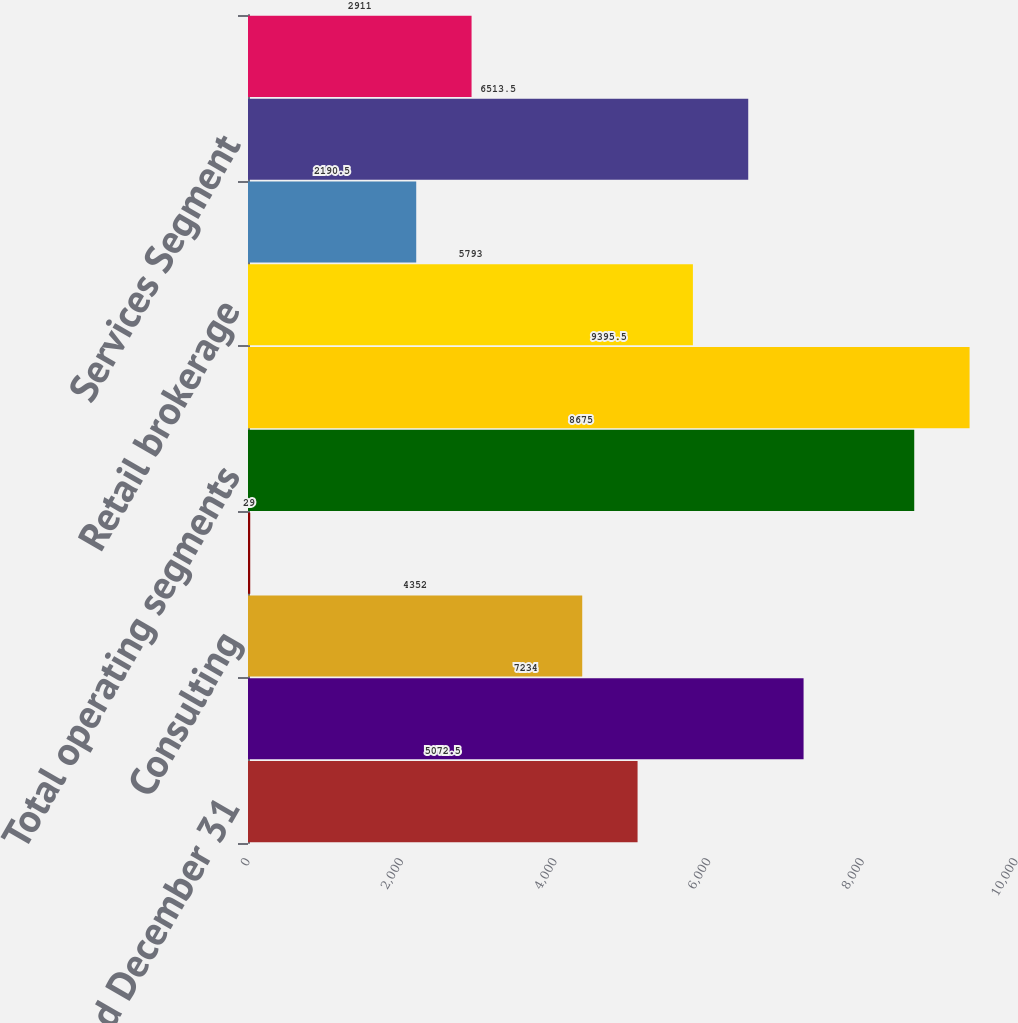<chart> <loc_0><loc_0><loc_500><loc_500><bar_chart><fcel>Years ended December 31<fcel>Risk and Insurance Brokerage<fcel>Consulting<fcel>Intersegment elimination<fcel>Total operating segments<fcel>Total revenue<fcel>Retail brokerage<fcel>Reinsurance brokerage<fcel>Services Segment<fcel>Consulting services<nl><fcel>5072.5<fcel>7234<fcel>4352<fcel>29<fcel>8675<fcel>9395.5<fcel>5793<fcel>2190.5<fcel>6513.5<fcel>2911<nl></chart> 